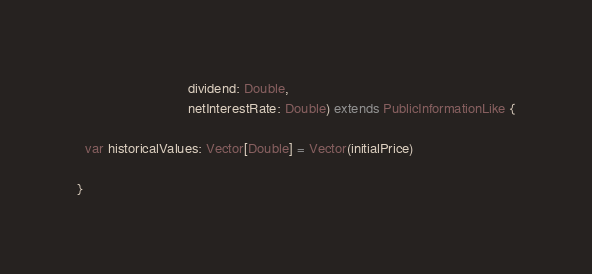Convert code to text. <code><loc_0><loc_0><loc_500><loc_500><_Scala_>                             dividend: Double,
                             netInterestRate: Double) extends PublicInformationLike {

  var historicalValues: Vector[Double] = Vector(initialPrice)

}
</code> 